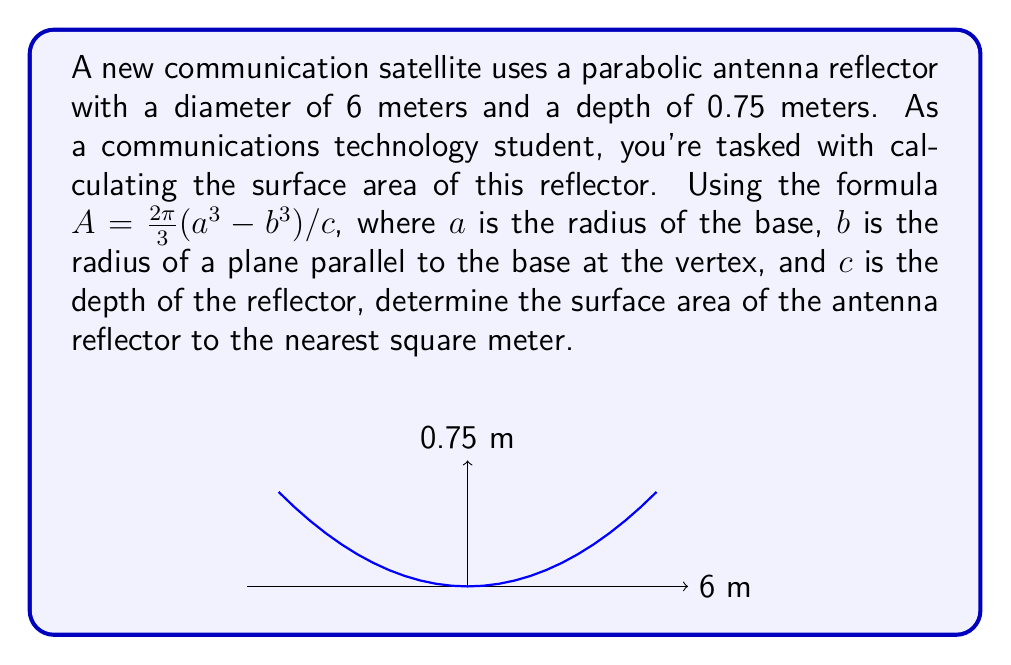What is the answer to this math problem? Let's approach this step-by-step:

1) First, we need to identify the values we know:
   - Diameter = 6 meters, so radius $a = 3$ meters
   - Depth $c = 0.75$ meters
   - $b = 0$ (at the vertex of the parabola)

2) We'll use the formula: $A = \frac{2\pi}{3}(a^3 - b^3)/c$

3) Substituting our known values:
   $A = \frac{2\pi}{3}(3^3 - 0^3)/0.75$

4) Simplify:
   $A = \frac{2\pi}{3}(27)/0.75$
   $A = \frac{2\pi \cdot 27}{3 \cdot 0.75}$
   $A = 18\pi$

5) Calculate:
   $A \approx 56.55$ square meters

6) Rounding to the nearest square meter:
   $A \approx 57$ square meters

This method uses the exact formula for the surface area of a paraboloid, which is particularly relevant for antenna design in communications technology. The formula accounts for the curvature of the parabolic surface, providing a more accurate result than approximating it as a flat disc.
Answer: $57$ square meters 